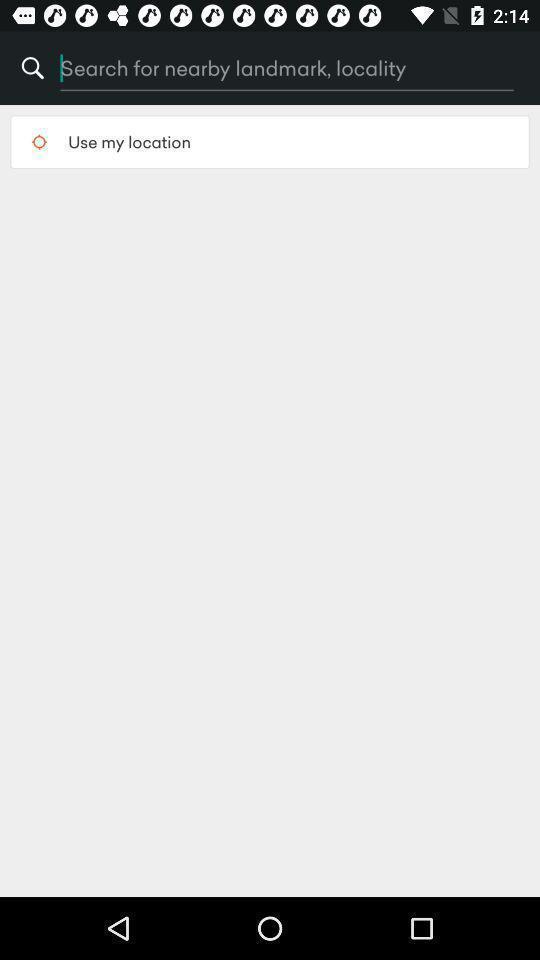What details can you identify in this image? Search page for searching a location. 